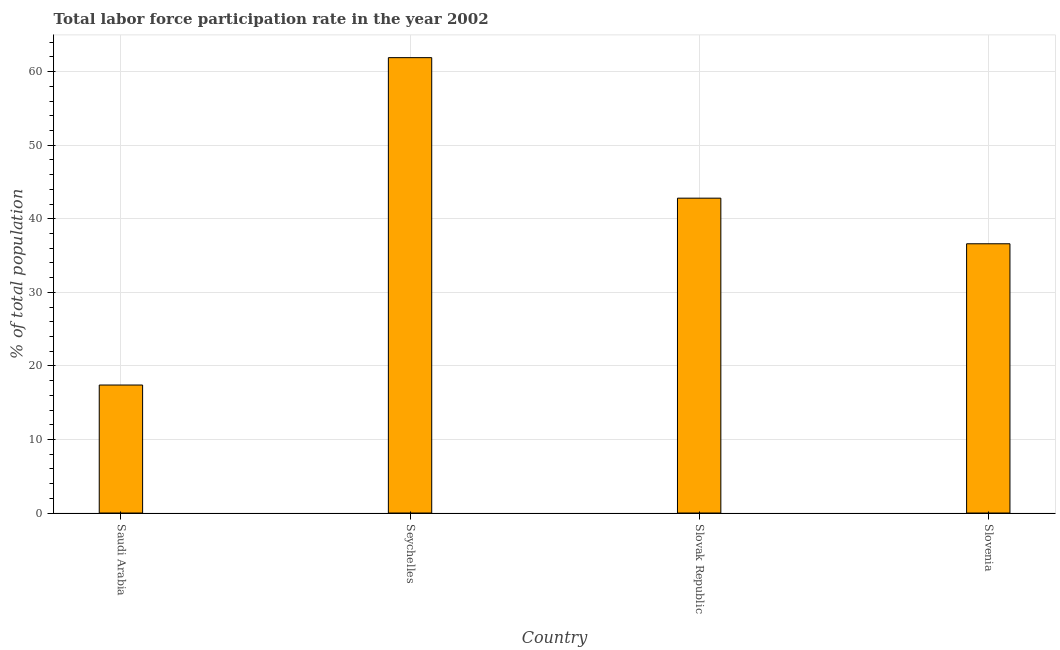Does the graph contain grids?
Give a very brief answer. Yes. What is the title of the graph?
Keep it short and to the point. Total labor force participation rate in the year 2002. What is the label or title of the X-axis?
Offer a terse response. Country. What is the label or title of the Y-axis?
Provide a succinct answer. % of total population. What is the total labor force participation rate in Seychelles?
Your answer should be very brief. 61.9. Across all countries, what is the maximum total labor force participation rate?
Keep it short and to the point. 61.9. Across all countries, what is the minimum total labor force participation rate?
Your answer should be very brief. 17.4. In which country was the total labor force participation rate maximum?
Provide a short and direct response. Seychelles. In which country was the total labor force participation rate minimum?
Ensure brevity in your answer.  Saudi Arabia. What is the sum of the total labor force participation rate?
Offer a very short reply. 158.7. What is the difference between the total labor force participation rate in Saudi Arabia and Slovenia?
Provide a succinct answer. -19.2. What is the average total labor force participation rate per country?
Offer a very short reply. 39.67. What is the median total labor force participation rate?
Ensure brevity in your answer.  39.7. What is the ratio of the total labor force participation rate in Seychelles to that in Slovenia?
Your response must be concise. 1.69. Is the total labor force participation rate in Saudi Arabia less than that in Slovak Republic?
Ensure brevity in your answer.  Yes. Is the difference between the total labor force participation rate in Seychelles and Slovak Republic greater than the difference between any two countries?
Provide a succinct answer. No. What is the difference between the highest and the lowest total labor force participation rate?
Your response must be concise. 44.5. In how many countries, is the total labor force participation rate greater than the average total labor force participation rate taken over all countries?
Your response must be concise. 2. What is the difference between two consecutive major ticks on the Y-axis?
Give a very brief answer. 10. What is the % of total population in Saudi Arabia?
Offer a very short reply. 17.4. What is the % of total population of Seychelles?
Ensure brevity in your answer.  61.9. What is the % of total population in Slovak Republic?
Offer a very short reply. 42.8. What is the % of total population in Slovenia?
Provide a succinct answer. 36.6. What is the difference between the % of total population in Saudi Arabia and Seychelles?
Provide a succinct answer. -44.5. What is the difference between the % of total population in Saudi Arabia and Slovak Republic?
Offer a terse response. -25.4. What is the difference between the % of total population in Saudi Arabia and Slovenia?
Your answer should be very brief. -19.2. What is the difference between the % of total population in Seychelles and Slovenia?
Provide a short and direct response. 25.3. What is the ratio of the % of total population in Saudi Arabia to that in Seychelles?
Provide a short and direct response. 0.28. What is the ratio of the % of total population in Saudi Arabia to that in Slovak Republic?
Your answer should be compact. 0.41. What is the ratio of the % of total population in Saudi Arabia to that in Slovenia?
Keep it short and to the point. 0.47. What is the ratio of the % of total population in Seychelles to that in Slovak Republic?
Provide a succinct answer. 1.45. What is the ratio of the % of total population in Seychelles to that in Slovenia?
Offer a terse response. 1.69. What is the ratio of the % of total population in Slovak Republic to that in Slovenia?
Keep it short and to the point. 1.17. 